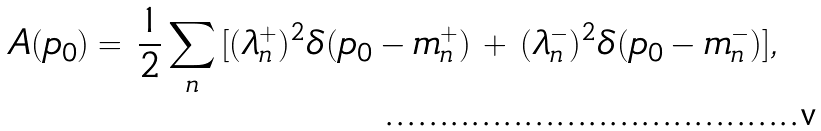<formula> <loc_0><loc_0><loc_500><loc_500>A ( p _ { 0 } ) = \, \frac { 1 } { 2 } \sum _ { n } \, [ ( \lambda _ { n } ^ { + } ) ^ { 2 } \delta ( p _ { 0 } - m _ { n } ^ { + } ) \, + \, ( \lambda _ { n } ^ { - } ) ^ { 2 } \delta ( p _ { 0 } - m _ { n } ^ { - } ) ] ,</formula> 